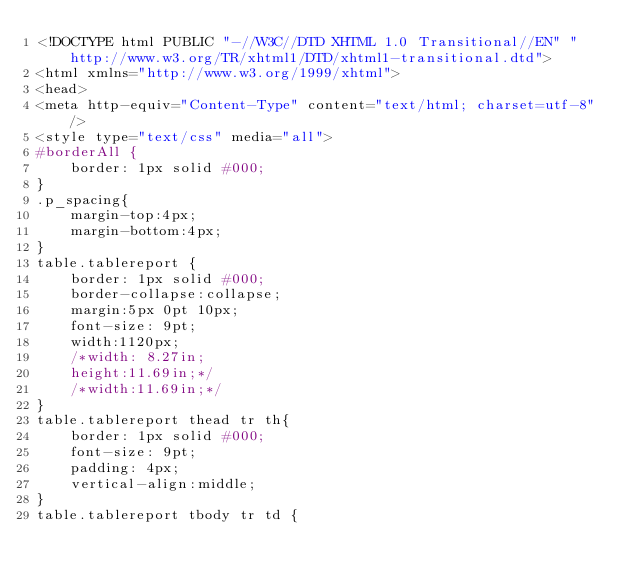<code> <loc_0><loc_0><loc_500><loc_500><_PHP_><!DOCTYPE html PUBLIC "-//W3C//DTD XHTML 1.0 Transitional//EN" "http://www.w3.org/TR/xhtml1/DTD/xhtml1-transitional.dtd">
<html xmlns="http://www.w3.org/1999/xhtml">
<head>
<meta http-equiv="Content-Type" content="text/html; charset=utf-8" />
<style type="text/css" media="all">	
#borderAll {
    border: 1px solid #000;	  	    
}
.p_spacing{
    margin-top:4px;
    margin-bottom:4px;
}
table.tablereport {	
    border: 1px solid #000;	
    border-collapse:collapse;
    margin:5px 0pt 10px;		
    font-size: 9pt;
	width:1120px;
    /*width: 8.27in;	
    height:11.69in;*/
	/*width:11.69in;*/
}
table.tablereport thead tr th{		
    border: 1px solid #000;		
    font-size: 9pt;		
    padding: 4px;
    vertical-align:middle;
}	
table.tablereport tbody tr td {</code> 